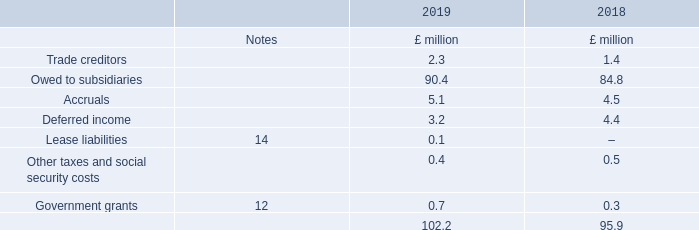10. Creditors: amounts falling due within one year
Trade creditors are non-interest bearing and are normally settled on 30 to 60-day terms. Other creditors are non-interest bearing.
The Directors consider that the carrying amount of trade creditors approximates their fair value.
What terms are trade creditors normally settled on? 30 to 60-day terms. What is the value of deferred income in 2019?
Answer scale should be: million. 3.2. What types of creditors are non-interest bearing? Trade creditors, other creditors. In which year was the amount of Accruals larger? 5.1>4.5
Answer: 2019. What was the change in Accruals?
Answer scale should be: million. 5.1-4.5
Answer: 0.6. What was the percentage change in Accruals?
Answer scale should be: percent. (5.1-4.5)/4.5
Answer: 13.33. 